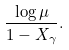<formula> <loc_0><loc_0><loc_500><loc_500>\frac { \log \mu } { 1 - X _ { \gamma } } .</formula> 